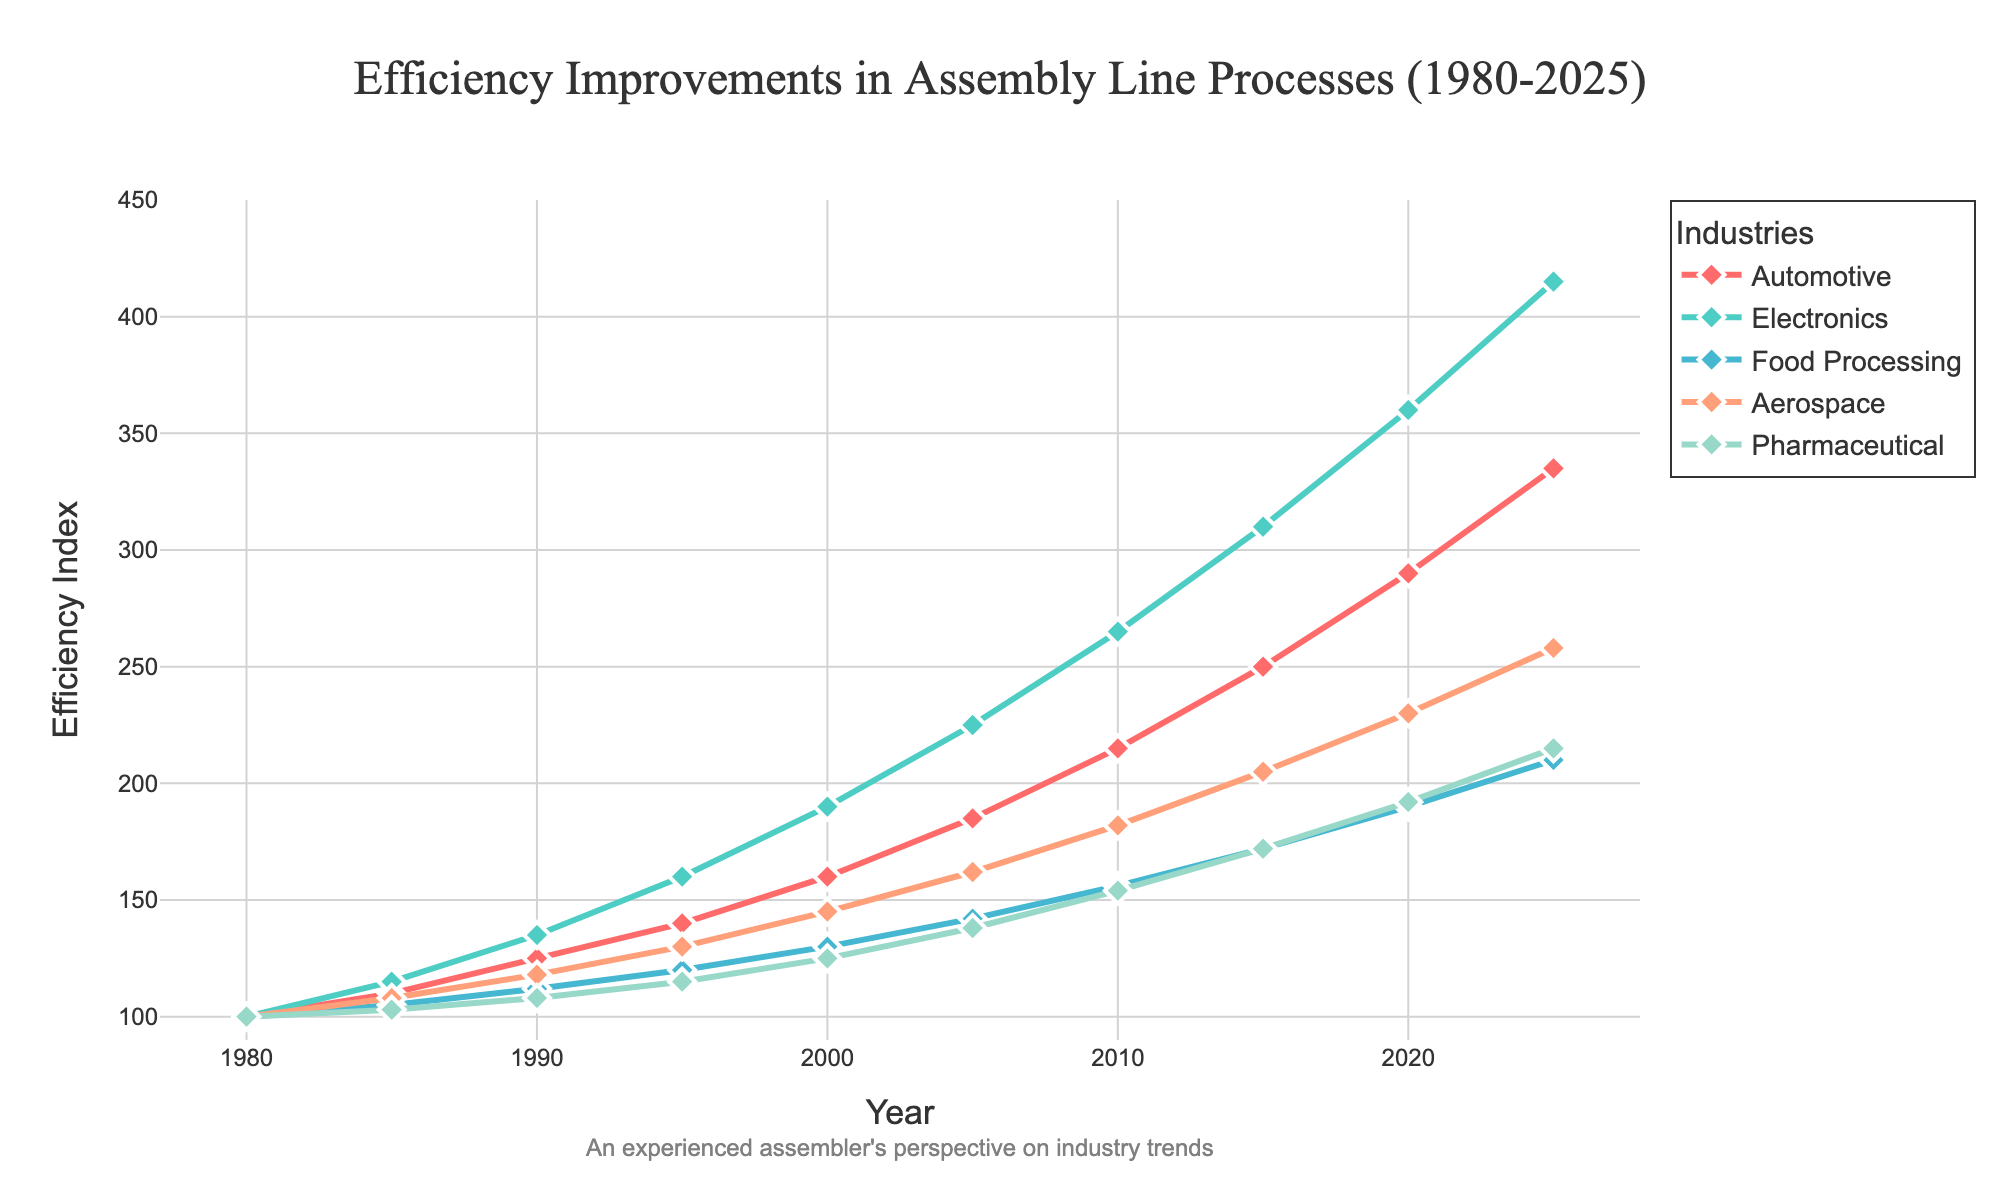What's the highest efficiency index achieved by the Automotive industry by 2025? The highest efficiency index can be found by checking the values in the Automotive industry's line in the figure. The peak value in the given data is 335 in 2025.
Answer: 335 Which industry showed the most significant increase in efficiency between 1980 and 2025? To determine the most significant increase, subtract the 1980 value from the 2025 value for each industry and compare the results. The increases are: Automotive (335 - 100 = 235), Electronics (415 - 100 = 315), Food Processing (210 - 100 = 110), Aerospace (258 - 100 = 158), Pharmaceutical (215 - 100 = 115). Electronics has the highest increase at 315.
Answer: Electronics In which year did the Food Processing industry's efficiency index first exceed 150? Track the Food Processing industry's line in the figure or check the efficiency values to find the first year it exceeded 150. The first value greater than 150 is in 2010, where it hit 156.
Answer: 2010 How does the efficiency index of Aerospace in 2020 compare to that of Pharmaceuticals in the same year? Look at the 2020 efficiency values for both Aerospace and Pharmaceuticals in the plot. Aerospace is 230 and Pharmaceuticals is 192. Aerospace is higher than Pharmaceuticals.
Answer: Aerospace is higher What is the average efficiency index of the Electronics industry over the entire period? Calculate the average by summing all the efficiency index values for Electronics and dividing by the number of years: (100 + 115 + 135 + 160 + 190 + 225 + 265 + 310 + 360 + 415) / 10 = 2275 / 10 = 227.5.
Answer: 227.5 Compare the efficiency index growth rate of the Food Processing industry to that of the Automotive industry from 1980 to 2025. Which is higher in percentage terms? Growth rate can be calculated using ((final value - initial value) / initial value) * 100. For Food Processing: ((210 - 100) / 100) * 100 = 110%, and for Automotive: ((335 - 100) / 100) * 100 = 235%. Automotive's growth rate is higher.
Answer: Automotive's growth rate is higher Which industry had the least variation in efficiency improvement over the years? The industry with the least variation will have the smallest range (difference between max and min values). Calculate the ranges for each industry: Automotive (335-100=235), Electronics (415-100=315), Food Processing (210-100=110), Aerospace (258-100=158), Pharmaceutical (215-100=115). Food Processing has the smallest range of 110.
Answer: Food Processing From 2010 to 2020, how many industries surpassed an efficiency index of 200 at any point in time? Check each industry’s efficiency index for the years 2010 and 2020. Automotive (215, 290), Electronics (265, 360), Food Processing (156, 190), Aerospace (182, 230), Pharmaceutical (154, 192). Only Automotive, Electronics, and Aerospace surpassed 200.
Answer: 3 industries 